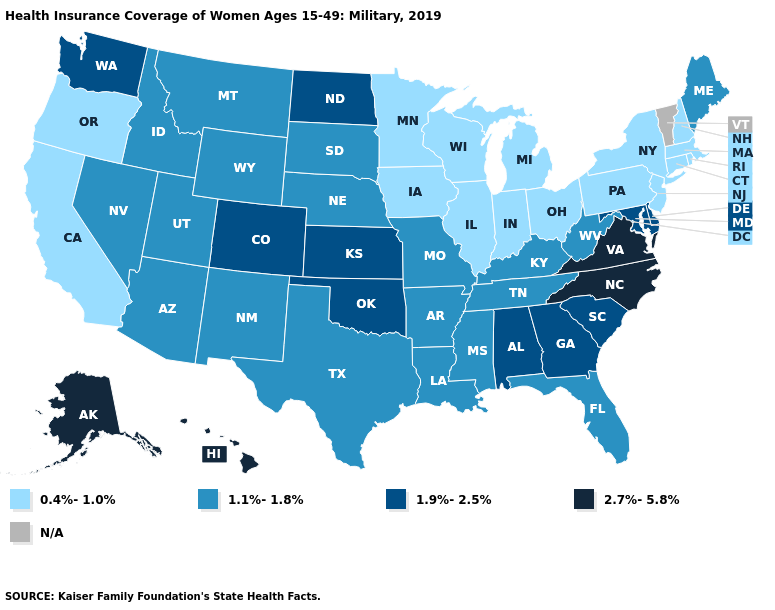What is the highest value in the West ?
Write a very short answer. 2.7%-5.8%. Name the states that have a value in the range N/A?
Answer briefly. Vermont. Name the states that have a value in the range 1.1%-1.8%?
Quick response, please. Arizona, Arkansas, Florida, Idaho, Kentucky, Louisiana, Maine, Mississippi, Missouri, Montana, Nebraska, Nevada, New Mexico, South Dakota, Tennessee, Texas, Utah, West Virginia, Wyoming. What is the highest value in states that border Nebraska?
Concise answer only. 1.9%-2.5%. Among the states that border North Carolina , does Tennessee have the highest value?
Quick response, please. No. Name the states that have a value in the range 1.1%-1.8%?
Quick response, please. Arizona, Arkansas, Florida, Idaho, Kentucky, Louisiana, Maine, Mississippi, Missouri, Montana, Nebraska, Nevada, New Mexico, South Dakota, Tennessee, Texas, Utah, West Virginia, Wyoming. Name the states that have a value in the range 2.7%-5.8%?
Write a very short answer. Alaska, Hawaii, North Carolina, Virginia. What is the value of Hawaii?
Answer briefly. 2.7%-5.8%. Does Mississippi have the lowest value in the South?
Quick response, please. Yes. What is the value of North Carolina?
Give a very brief answer. 2.7%-5.8%. What is the value of Connecticut?
Answer briefly. 0.4%-1.0%. Which states hav the highest value in the West?
Quick response, please. Alaska, Hawaii. What is the lowest value in states that border Iowa?
Give a very brief answer. 0.4%-1.0%. 